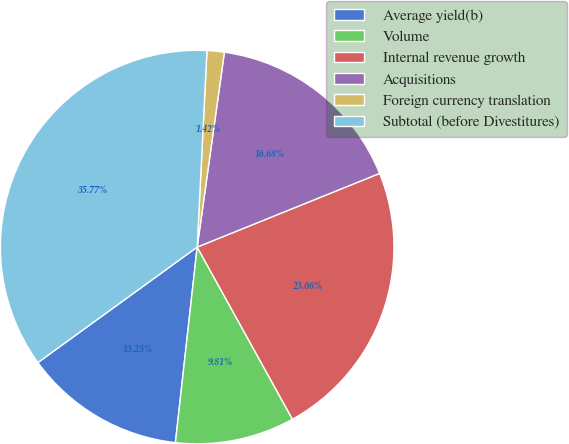<chart> <loc_0><loc_0><loc_500><loc_500><pie_chart><fcel>Average yield(b)<fcel>Volume<fcel>Internal revenue growth<fcel>Acquisitions<fcel>Foreign currency translation<fcel>Subtotal (before Divestitures)<nl><fcel>13.25%<fcel>9.81%<fcel>23.06%<fcel>16.68%<fcel>1.42%<fcel>35.77%<nl></chart> 